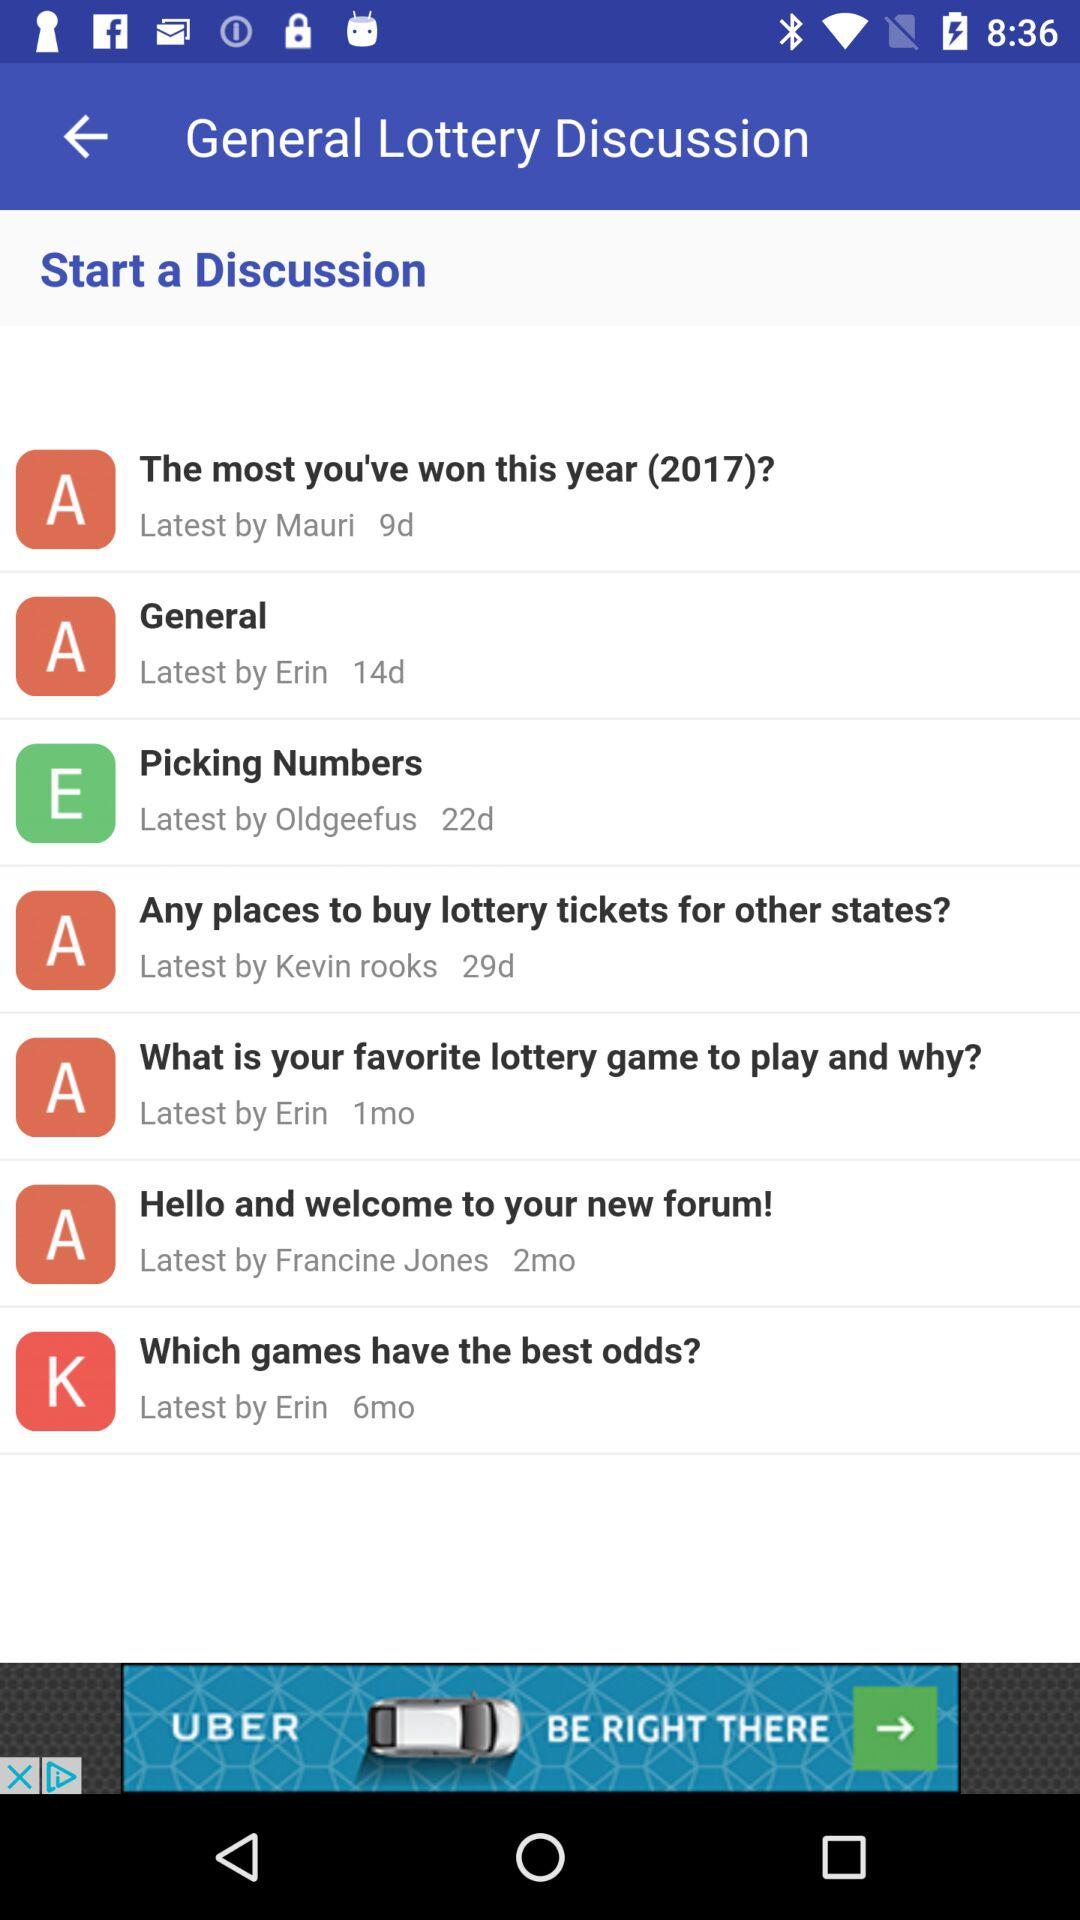How many days has it been since the latest discussion on the topic 'The most you've won this year (2017)?'
Answer the question using a single word or phrase. 9 